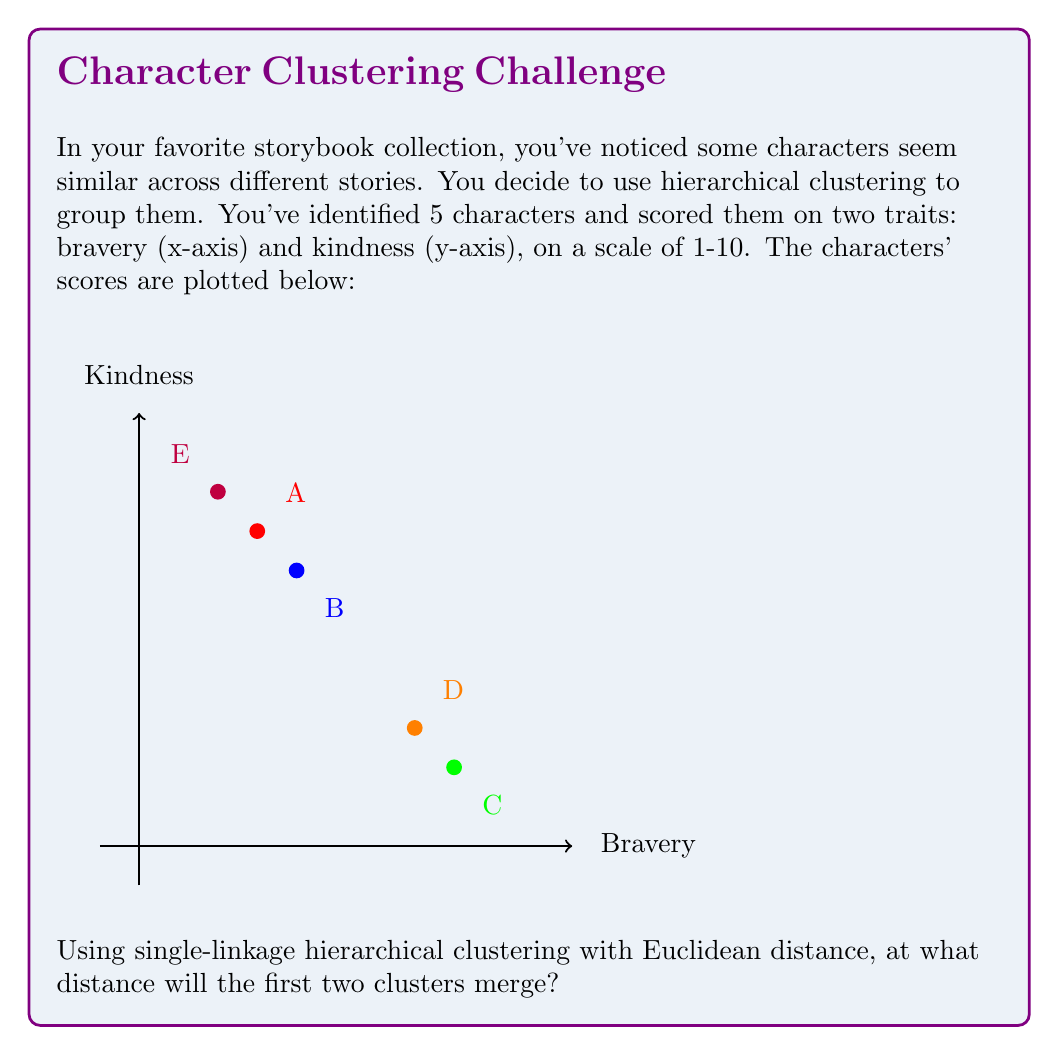What is the answer to this math problem? Let's approach this step-by-step:

1) First, we need to calculate the Euclidean distances between all pairs of points. The Euclidean distance formula is:

   $$d = \sqrt{(x_2 - x_1)^2 + (y_2 - y_1)^2}$$

2) Let's calculate all distances:
   
   AB: $\sqrt{(4-3)^2 + (7-8)^2} = \sqrt{1 + 1} = \sqrt{2} \approx 1.41$
   AC: $\sqrt{(8-3)^2 + (2-8)^2} = \sqrt{25 + 36} = \sqrt{61} \approx 7.81$
   AD: $\sqrt{(7-3)^2 + (3-8)^2} = \sqrt{16 + 25} = \sqrt{41} \approx 6.40$
   AE: $\sqrt{(2-3)^2 + (9-8)^2} = \sqrt{1 + 1} = \sqrt{2} \approx 1.41$
   BC: $\sqrt{(8-4)^2 + (2-7)^2} = \sqrt{16 + 25} = \sqrt{41} \approx 6.40$
   BD: $\sqrt{(7-4)^2 + (3-7)^2} = \sqrt{9 + 16} = 5$
   BE: $\sqrt{(2-4)^2 + (9-7)^2} = \sqrt{4 + 4} = \sqrt{8} \approx 2.83$
   CD: $\sqrt{(7-8)^2 + (3-2)^2} = \sqrt{1 + 1} = \sqrt{2} \approx 1.41$
   CE: $\sqrt{(2-8)^2 + (9-2)^2} = \sqrt{36 + 49} = \sqrt{85} \approx 9.22$
   DE: $\sqrt{(2-7)^2 + (9-3)^2} = \sqrt{25 + 36} = \sqrt{61} \approx 7.81$

3) In single-linkage clustering, we merge the clusters with the smallest distance between any of their members.

4) The smallest distance we calculated is $\sqrt{2} \approx 1.41$, which occurs between pairs AB, AE, and CD.

5) This means that at a distance of $\sqrt{2}$, we will have our first merge, creating two clusters: {A,B,E} and {C,D}.

Therefore, the first two clusters will merge at a distance of $\sqrt{2}$.
Answer: $\sqrt{2}$ 